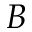Convert formula to latex. <formula><loc_0><loc_0><loc_500><loc_500>B</formula> 